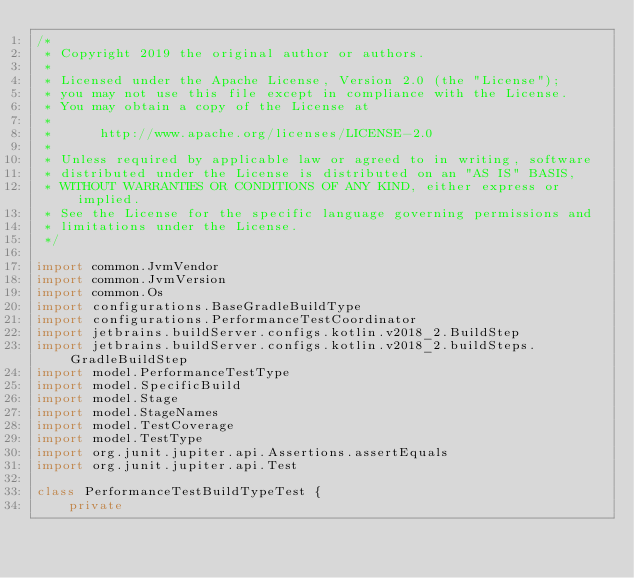<code> <loc_0><loc_0><loc_500><loc_500><_Kotlin_>/*
 * Copyright 2019 the original author or authors.
 *
 * Licensed under the Apache License, Version 2.0 (the "License");
 * you may not use this file except in compliance with the License.
 * You may obtain a copy of the License at
 *
 *      http://www.apache.org/licenses/LICENSE-2.0
 *
 * Unless required by applicable law or agreed to in writing, software
 * distributed under the License is distributed on an "AS IS" BASIS,
 * WITHOUT WARRANTIES OR CONDITIONS OF ANY KIND, either express or implied.
 * See the License for the specific language governing permissions and
 * limitations under the License.
 */

import common.JvmVendor
import common.JvmVersion
import common.Os
import configurations.BaseGradleBuildType
import configurations.PerformanceTestCoordinator
import jetbrains.buildServer.configs.kotlin.v2018_2.BuildStep
import jetbrains.buildServer.configs.kotlin.v2018_2.buildSteps.GradleBuildStep
import model.PerformanceTestType
import model.SpecificBuild
import model.Stage
import model.StageNames
import model.TestCoverage
import model.TestType
import org.junit.jupiter.api.Assertions.assertEquals
import org.junit.jupiter.api.Test

class PerformanceTestBuildTypeTest {
    private</code> 